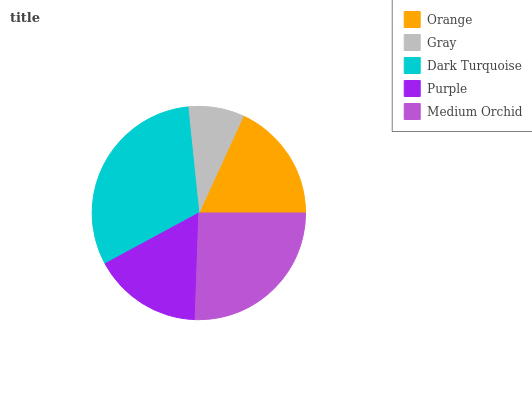Is Gray the minimum?
Answer yes or no. Yes. Is Dark Turquoise the maximum?
Answer yes or no. Yes. Is Dark Turquoise the minimum?
Answer yes or no. No. Is Gray the maximum?
Answer yes or no. No. Is Dark Turquoise greater than Gray?
Answer yes or no. Yes. Is Gray less than Dark Turquoise?
Answer yes or no. Yes. Is Gray greater than Dark Turquoise?
Answer yes or no. No. Is Dark Turquoise less than Gray?
Answer yes or no. No. Is Orange the high median?
Answer yes or no. Yes. Is Orange the low median?
Answer yes or no. Yes. Is Dark Turquoise the high median?
Answer yes or no. No. Is Medium Orchid the low median?
Answer yes or no. No. 